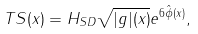Convert formula to latex. <formula><loc_0><loc_0><loc_500><loc_500>T S ( x ) = H _ { S D } \sqrt { | g | ( x ) } e ^ { 6 \hat { \phi } ( x ) } ,</formula> 